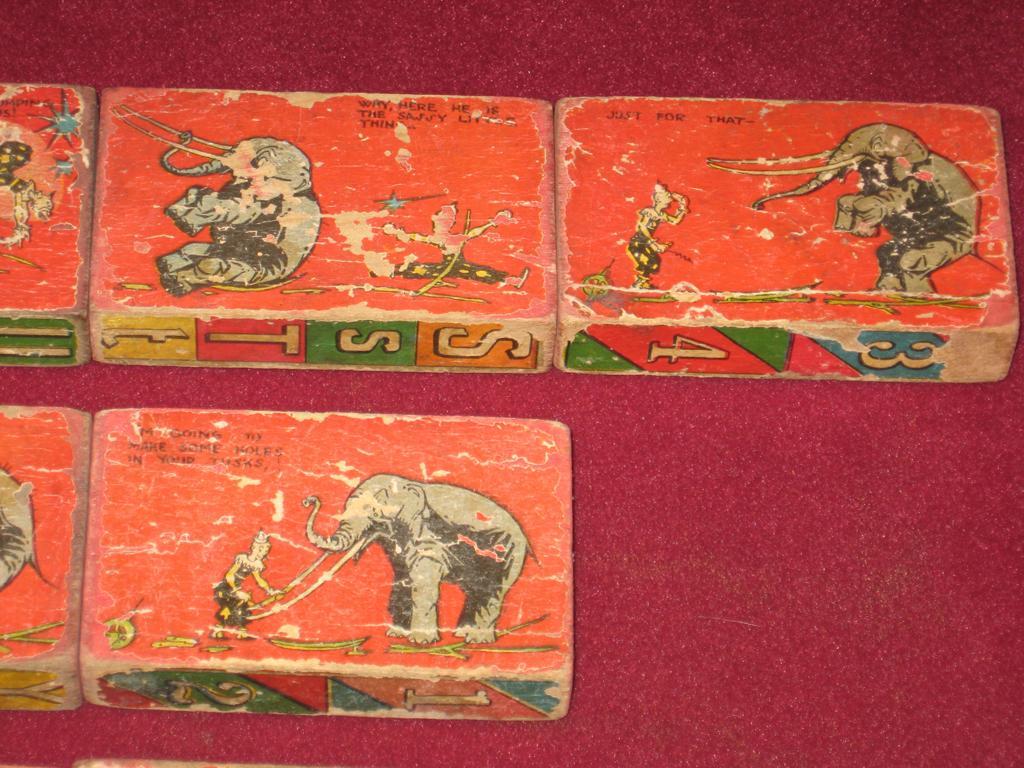In one or two sentences, can you explain what this image depicts? In this image there are some boxes, on the boxes there is some text and in the background there is a floor. 